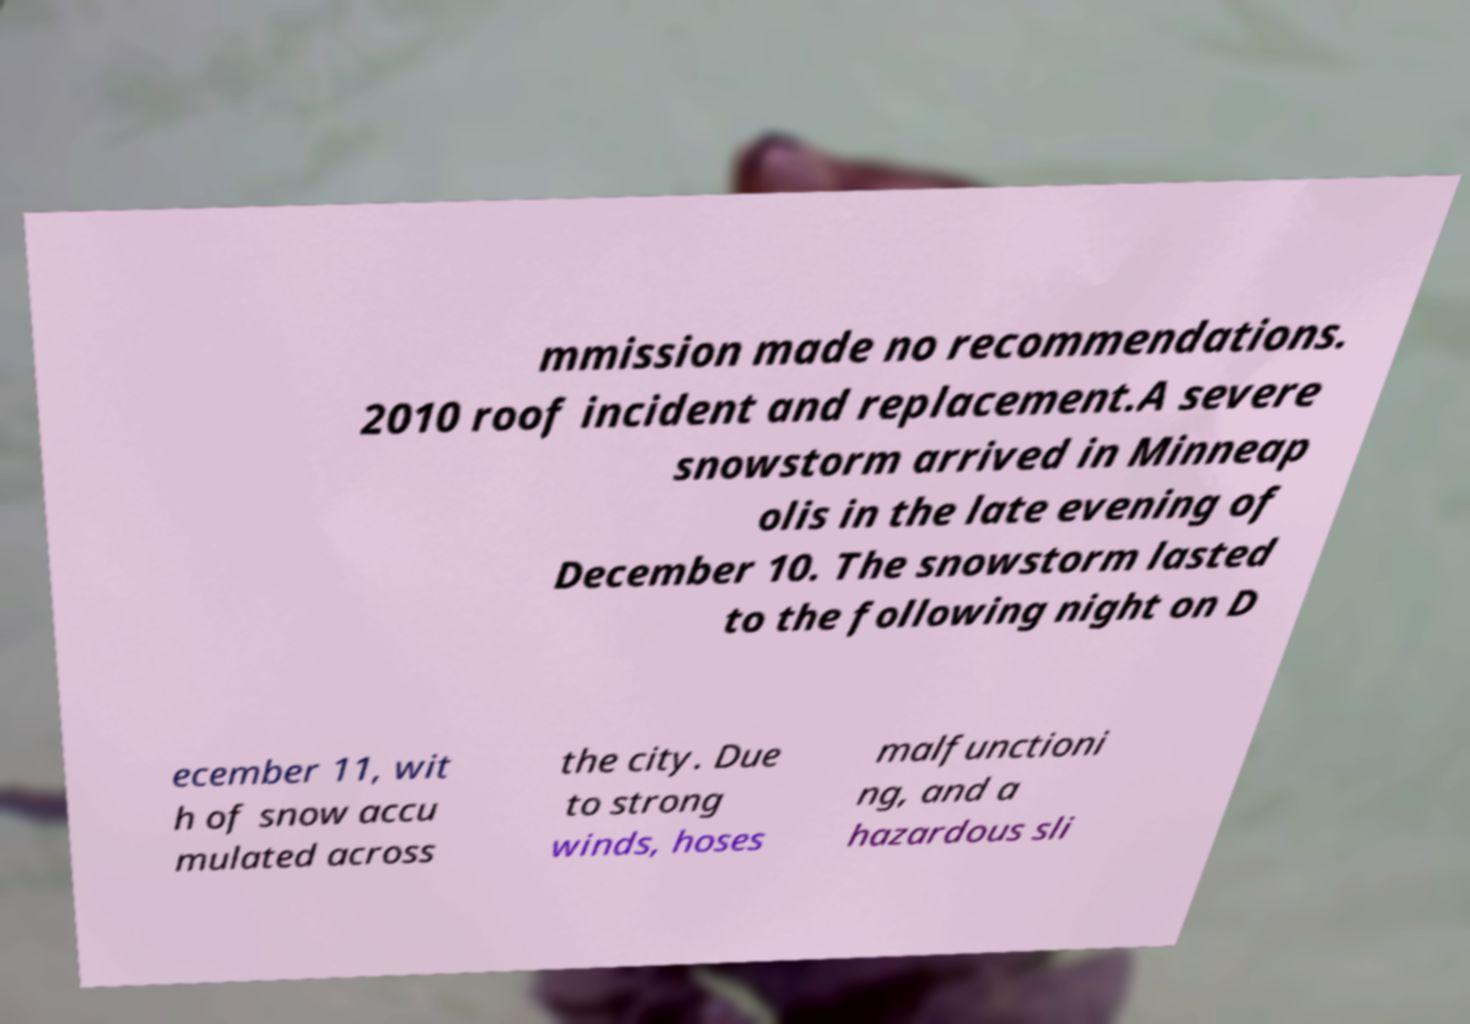Please identify and transcribe the text found in this image. mmission made no recommendations. 2010 roof incident and replacement.A severe snowstorm arrived in Minneap olis in the late evening of December 10. The snowstorm lasted to the following night on D ecember 11, wit h of snow accu mulated across the city. Due to strong winds, hoses malfunctioni ng, and a hazardous sli 